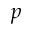<formula> <loc_0><loc_0><loc_500><loc_500>p</formula> 